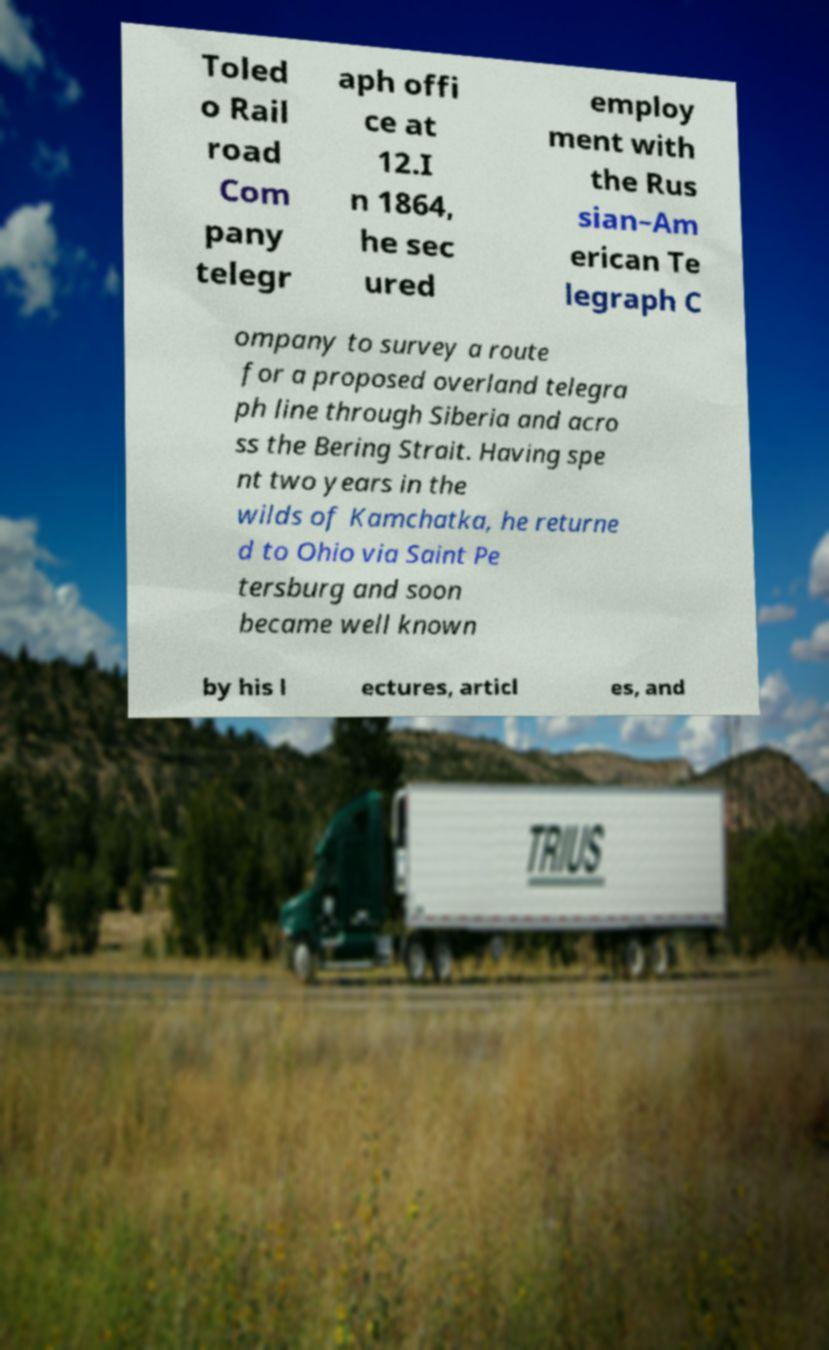What messages or text are displayed in this image? I need them in a readable, typed format. Toled o Rail road Com pany telegr aph offi ce at 12.I n 1864, he sec ured employ ment with the Rus sian–Am erican Te legraph C ompany to survey a route for a proposed overland telegra ph line through Siberia and acro ss the Bering Strait. Having spe nt two years in the wilds of Kamchatka, he returne d to Ohio via Saint Pe tersburg and soon became well known by his l ectures, articl es, and 